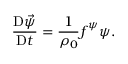Convert formula to latex. <formula><loc_0><loc_0><loc_500><loc_500>\frac { D \vec { \psi } } { D t } = \frac { 1 } { \rho _ { 0 } } f ^ { \psi } \psi .</formula> 